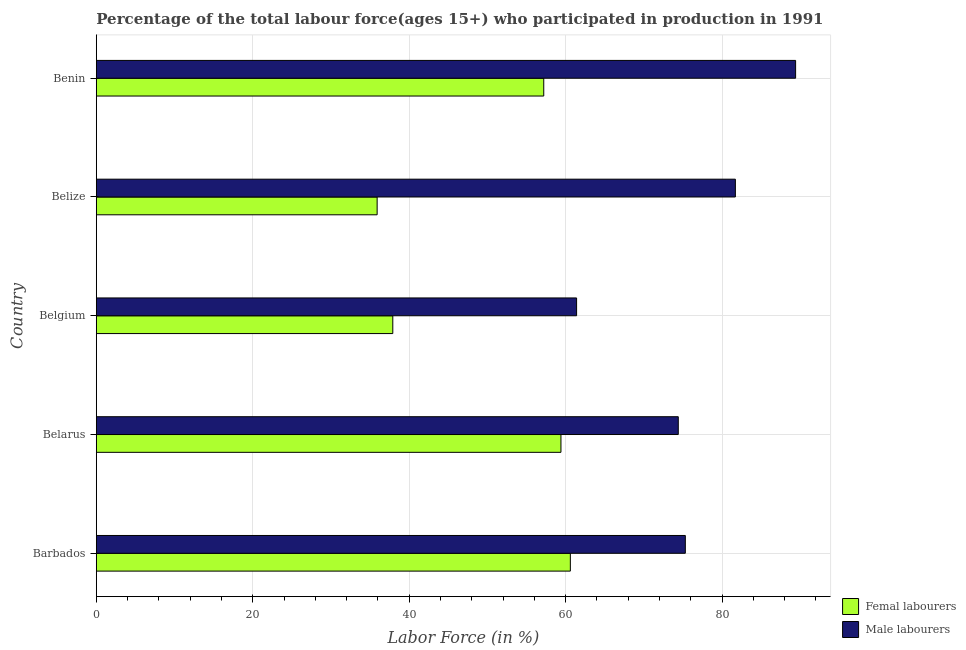How many groups of bars are there?
Offer a very short reply. 5. Are the number of bars per tick equal to the number of legend labels?
Your response must be concise. Yes. How many bars are there on the 1st tick from the bottom?
Offer a very short reply. 2. In how many cases, is the number of bars for a given country not equal to the number of legend labels?
Ensure brevity in your answer.  0. What is the percentage of female labor force in Barbados?
Provide a succinct answer. 60.6. Across all countries, what is the maximum percentage of female labor force?
Offer a very short reply. 60.6. Across all countries, what is the minimum percentage of male labour force?
Ensure brevity in your answer.  61.4. In which country was the percentage of male labour force maximum?
Ensure brevity in your answer.  Benin. In which country was the percentage of female labor force minimum?
Give a very brief answer. Belize. What is the total percentage of male labour force in the graph?
Keep it short and to the point. 382.2. What is the difference between the percentage of male labour force in Barbados and that in Belarus?
Provide a succinct answer. 0.9. What is the difference between the percentage of male labour force in Barbados and the percentage of female labor force in Belize?
Give a very brief answer. 39.4. What is the average percentage of male labour force per country?
Offer a very short reply. 76.44. What is the difference between the percentage of male labour force and percentage of female labor force in Barbados?
Ensure brevity in your answer.  14.7. In how many countries, is the percentage of female labor force greater than 80 %?
Give a very brief answer. 0. What is the ratio of the percentage of female labor force in Belize to that in Benin?
Give a very brief answer. 0.63. What is the difference between the highest and the lowest percentage of female labor force?
Offer a very short reply. 24.7. What does the 1st bar from the top in Barbados represents?
Make the answer very short. Male labourers. What does the 2nd bar from the bottom in Barbados represents?
Offer a very short reply. Male labourers. What is the difference between two consecutive major ticks on the X-axis?
Provide a short and direct response. 20. Where does the legend appear in the graph?
Provide a short and direct response. Bottom right. How many legend labels are there?
Ensure brevity in your answer.  2. How are the legend labels stacked?
Provide a succinct answer. Vertical. What is the title of the graph?
Provide a short and direct response. Percentage of the total labour force(ages 15+) who participated in production in 1991. Does "Age 65(male)" appear as one of the legend labels in the graph?
Ensure brevity in your answer.  No. What is the label or title of the Y-axis?
Give a very brief answer. Country. What is the Labor Force (in %) in Femal labourers in Barbados?
Your answer should be very brief. 60.6. What is the Labor Force (in %) in Male labourers in Barbados?
Give a very brief answer. 75.3. What is the Labor Force (in %) of Femal labourers in Belarus?
Make the answer very short. 59.4. What is the Labor Force (in %) of Male labourers in Belarus?
Your response must be concise. 74.4. What is the Labor Force (in %) in Femal labourers in Belgium?
Provide a short and direct response. 37.9. What is the Labor Force (in %) in Male labourers in Belgium?
Your answer should be compact. 61.4. What is the Labor Force (in %) of Femal labourers in Belize?
Give a very brief answer. 35.9. What is the Labor Force (in %) of Male labourers in Belize?
Provide a succinct answer. 81.7. What is the Labor Force (in %) in Femal labourers in Benin?
Give a very brief answer. 57.2. What is the Labor Force (in %) of Male labourers in Benin?
Offer a terse response. 89.4. Across all countries, what is the maximum Labor Force (in %) of Femal labourers?
Your response must be concise. 60.6. Across all countries, what is the maximum Labor Force (in %) in Male labourers?
Keep it short and to the point. 89.4. Across all countries, what is the minimum Labor Force (in %) of Femal labourers?
Your answer should be compact. 35.9. Across all countries, what is the minimum Labor Force (in %) in Male labourers?
Your answer should be very brief. 61.4. What is the total Labor Force (in %) of Femal labourers in the graph?
Ensure brevity in your answer.  251. What is the total Labor Force (in %) of Male labourers in the graph?
Provide a succinct answer. 382.2. What is the difference between the Labor Force (in %) of Male labourers in Barbados and that in Belarus?
Make the answer very short. 0.9. What is the difference between the Labor Force (in %) of Femal labourers in Barbados and that in Belgium?
Offer a very short reply. 22.7. What is the difference between the Labor Force (in %) in Male labourers in Barbados and that in Belgium?
Your answer should be compact. 13.9. What is the difference between the Labor Force (in %) in Femal labourers in Barbados and that in Belize?
Offer a terse response. 24.7. What is the difference between the Labor Force (in %) of Male labourers in Barbados and that in Belize?
Offer a very short reply. -6.4. What is the difference between the Labor Force (in %) of Male labourers in Barbados and that in Benin?
Your answer should be very brief. -14.1. What is the difference between the Labor Force (in %) in Femal labourers in Belgium and that in Belize?
Provide a short and direct response. 2. What is the difference between the Labor Force (in %) of Male labourers in Belgium and that in Belize?
Provide a short and direct response. -20.3. What is the difference between the Labor Force (in %) in Femal labourers in Belgium and that in Benin?
Make the answer very short. -19.3. What is the difference between the Labor Force (in %) of Femal labourers in Belize and that in Benin?
Give a very brief answer. -21.3. What is the difference between the Labor Force (in %) of Male labourers in Belize and that in Benin?
Give a very brief answer. -7.7. What is the difference between the Labor Force (in %) in Femal labourers in Barbados and the Labor Force (in %) in Male labourers in Belgium?
Provide a short and direct response. -0.8. What is the difference between the Labor Force (in %) of Femal labourers in Barbados and the Labor Force (in %) of Male labourers in Belize?
Make the answer very short. -21.1. What is the difference between the Labor Force (in %) of Femal labourers in Barbados and the Labor Force (in %) of Male labourers in Benin?
Your answer should be compact. -28.8. What is the difference between the Labor Force (in %) in Femal labourers in Belarus and the Labor Force (in %) in Male labourers in Belize?
Provide a short and direct response. -22.3. What is the difference between the Labor Force (in %) in Femal labourers in Belarus and the Labor Force (in %) in Male labourers in Benin?
Ensure brevity in your answer.  -30. What is the difference between the Labor Force (in %) of Femal labourers in Belgium and the Labor Force (in %) of Male labourers in Belize?
Your response must be concise. -43.8. What is the difference between the Labor Force (in %) in Femal labourers in Belgium and the Labor Force (in %) in Male labourers in Benin?
Ensure brevity in your answer.  -51.5. What is the difference between the Labor Force (in %) of Femal labourers in Belize and the Labor Force (in %) of Male labourers in Benin?
Your answer should be very brief. -53.5. What is the average Labor Force (in %) of Femal labourers per country?
Your answer should be compact. 50.2. What is the average Labor Force (in %) of Male labourers per country?
Provide a short and direct response. 76.44. What is the difference between the Labor Force (in %) of Femal labourers and Labor Force (in %) of Male labourers in Barbados?
Ensure brevity in your answer.  -14.7. What is the difference between the Labor Force (in %) of Femal labourers and Labor Force (in %) of Male labourers in Belarus?
Give a very brief answer. -15. What is the difference between the Labor Force (in %) of Femal labourers and Labor Force (in %) of Male labourers in Belgium?
Make the answer very short. -23.5. What is the difference between the Labor Force (in %) of Femal labourers and Labor Force (in %) of Male labourers in Belize?
Your response must be concise. -45.8. What is the difference between the Labor Force (in %) in Femal labourers and Labor Force (in %) in Male labourers in Benin?
Provide a short and direct response. -32.2. What is the ratio of the Labor Force (in %) in Femal labourers in Barbados to that in Belarus?
Your answer should be very brief. 1.02. What is the ratio of the Labor Force (in %) of Male labourers in Barbados to that in Belarus?
Ensure brevity in your answer.  1.01. What is the ratio of the Labor Force (in %) of Femal labourers in Barbados to that in Belgium?
Keep it short and to the point. 1.6. What is the ratio of the Labor Force (in %) of Male labourers in Barbados to that in Belgium?
Provide a succinct answer. 1.23. What is the ratio of the Labor Force (in %) of Femal labourers in Barbados to that in Belize?
Your answer should be compact. 1.69. What is the ratio of the Labor Force (in %) in Male labourers in Barbados to that in Belize?
Offer a terse response. 0.92. What is the ratio of the Labor Force (in %) of Femal labourers in Barbados to that in Benin?
Keep it short and to the point. 1.06. What is the ratio of the Labor Force (in %) of Male labourers in Barbados to that in Benin?
Your answer should be very brief. 0.84. What is the ratio of the Labor Force (in %) of Femal labourers in Belarus to that in Belgium?
Your answer should be compact. 1.57. What is the ratio of the Labor Force (in %) of Male labourers in Belarus to that in Belgium?
Ensure brevity in your answer.  1.21. What is the ratio of the Labor Force (in %) in Femal labourers in Belarus to that in Belize?
Give a very brief answer. 1.65. What is the ratio of the Labor Force (in %) of Male labourers in Belarus to that in Belize?
Provide a succinct answer. 0.91. What is the ratio of the Labor Force (in %) of Male labourers in Belarus to that in Benin?
Offer a very short reply. 0.83. What is the ratio of the Labor Force (in %) in Femal labourers in Belgium to that in Belize?
Make the answer very short. 1.06. What is the ratio of the Labor Force (in %) of Male labourers in Belgium to that in Belize?
Keep it short and to the point. 0.75. What is the ratio of the Labor Force (in %) in Femal labourers in Belgium to that in Benin?
Your answer should be compact. 0.66. What is the ratio of the Labor Force (in %) of Male labourers in Belgium to that in Benin?
Your answer should be very brief. 0.69. What is the ratio of the Labor Force (in %) in Femal labourers in Belize to that in Benin?
Keep it short and to the point. 0.63. What is the ratio of the Labor Force (in %) of Male labourers in Belize to that in Benin?
Provide a short and direct response. 0.91. What is the difference between the highest and the lowest Labor Force (in %) in Femal labourers?
Offer a terse response. 24.7. What is the difference between the highest and the lowest Labor Force (in %) in Male labourers?
Your response must be concise. 28. 